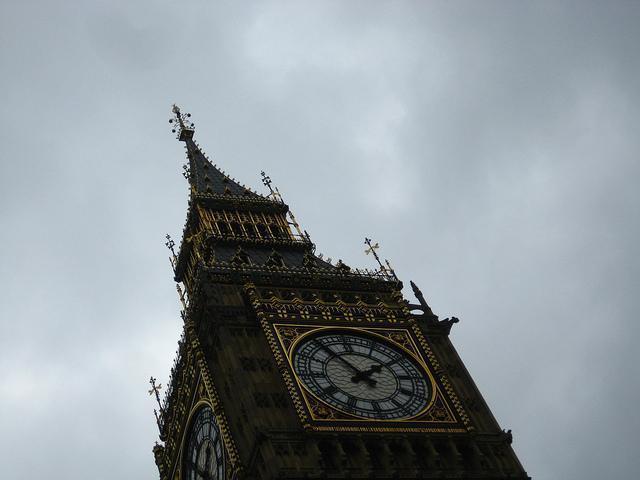How many clocks can be seen?
Give a very brief answer. 2. 